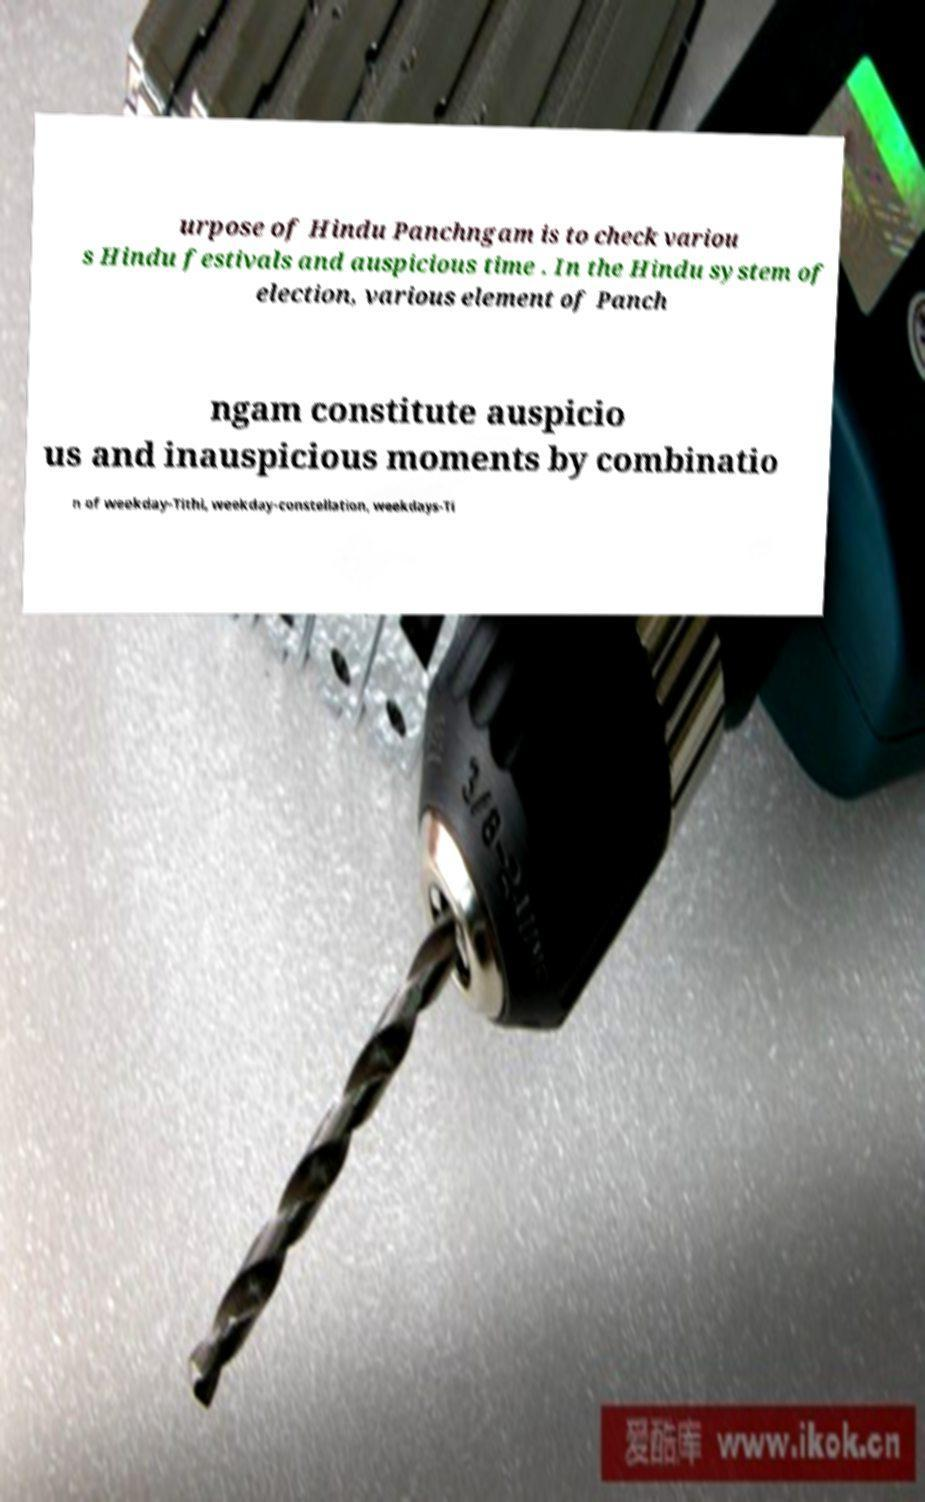Can you accurately transcribe the text from the provided image for me? urpose of Hindu Panchngam is to check variou s Hindu festivals and auspicious time . In the Hindu system of election, various element of Panch ngam constitute auspicio us and inauspicious moments by combinatio n of weekday-Tithi, weekday-constellation, weekdays-Ti 